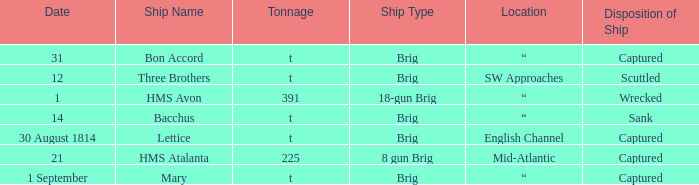Where was the ship when the ship had captured as the disposition of ship and was carrying 225 tonnage? Mid-Atlantic. 